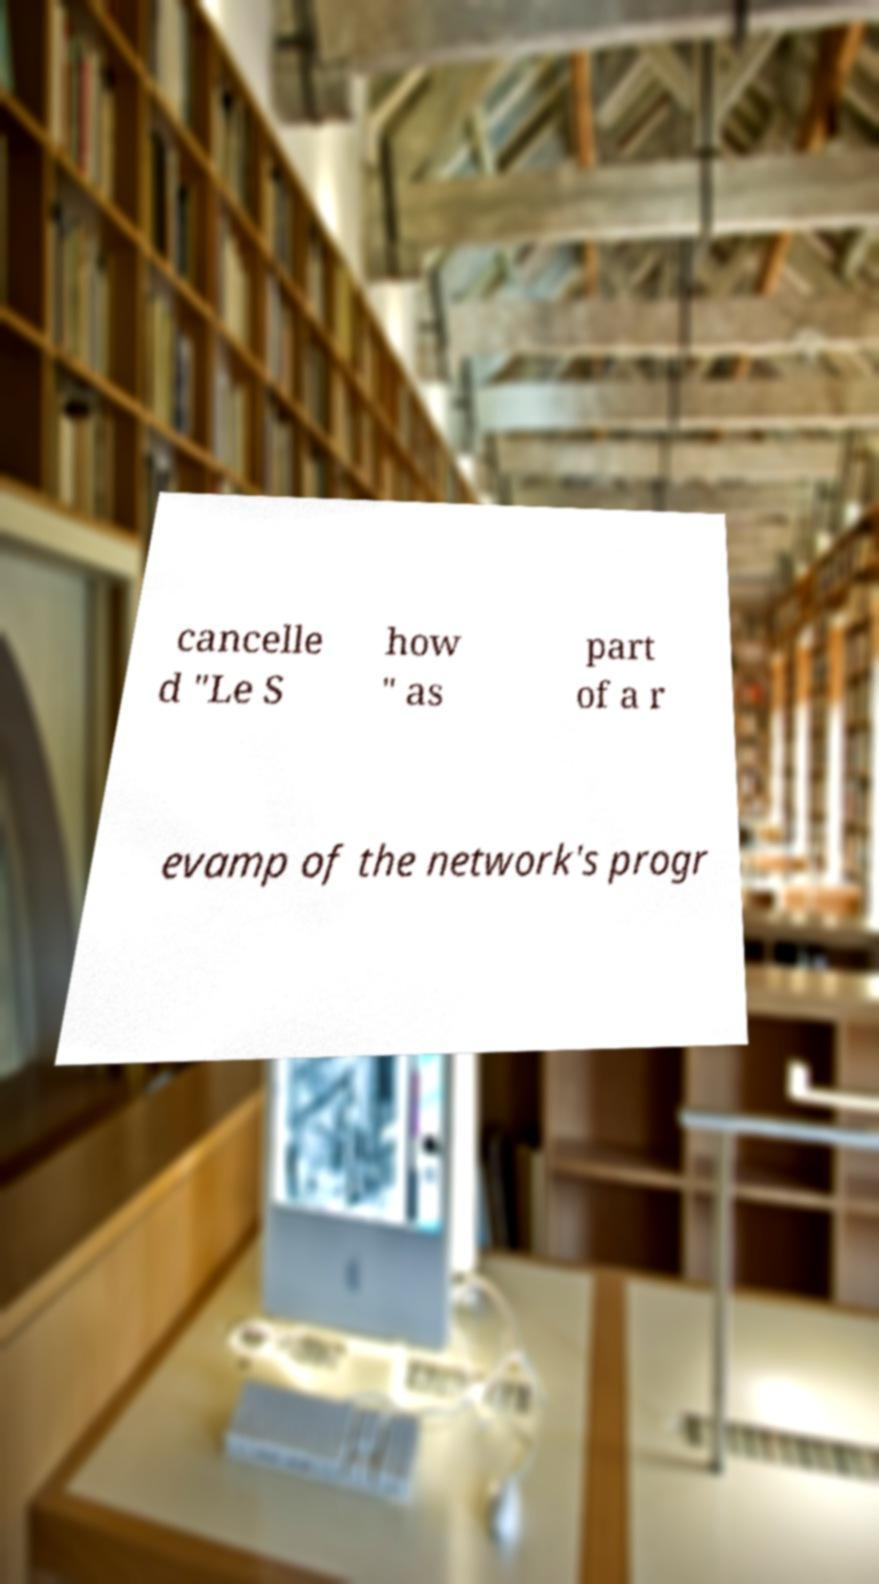For documentation purposes, I need the text within this image transcribed. Could you provide that? cancelle d "Le S how " as part of a r evamp of the network's progr 